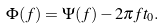Convert formula to latex. <formula><loc_0><loc_0><loc_500><loc_500>\Phi ( f ) = \Psi ( f ) - 2 \pi f t _ { 0 } .</formula> 